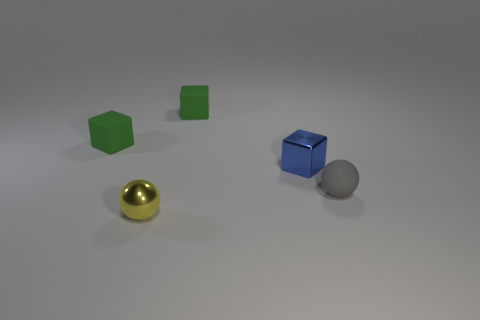Add 1 tiny gray matte spheres. How many objects exist? 6 Subtract all spheres. How many objects are left? 3 Subtract 1 gray balls. How many objects are left? 4 Subtract all yellow shiny spheres. Subtract all small green matte cubes. How many objects are left? 2 Add 3 gray rubber things. How many gray rubber things are left? 4 Add 2 tiny objects. How many tiny objects exist? 7 